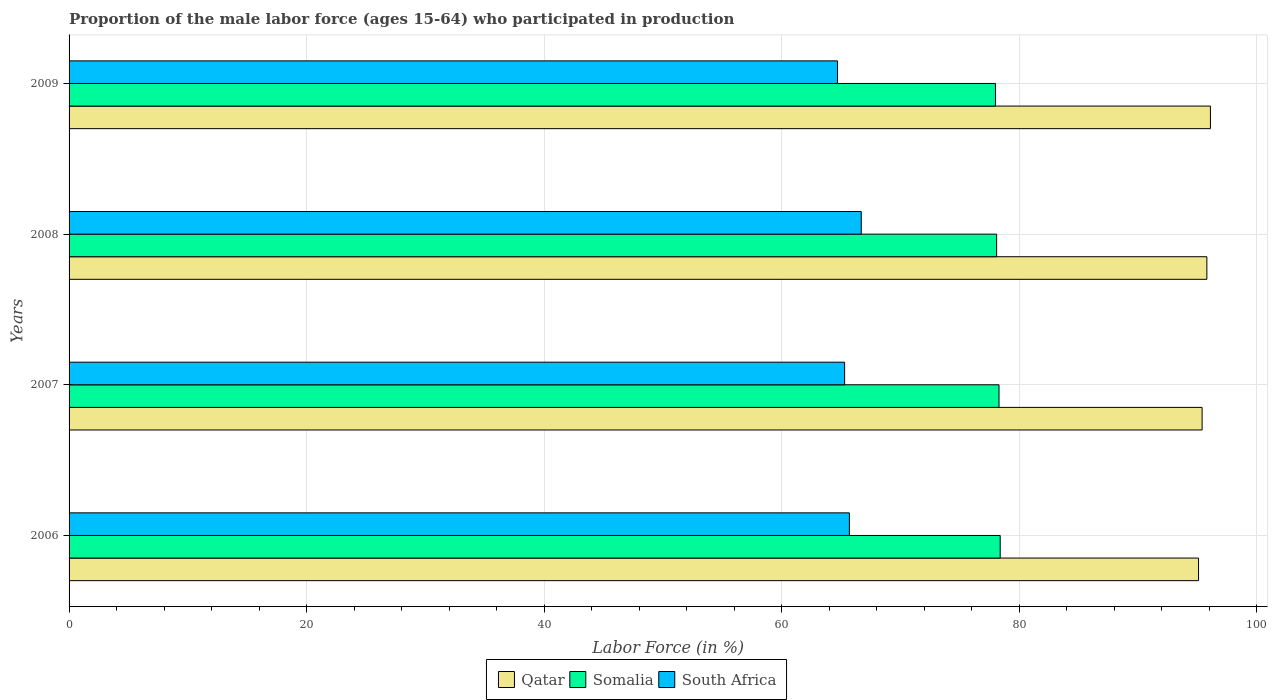How many groups of bars are there?
Offer a very short reply. 4. Are the number of bars on each tick of the Y-axis equal?
Give a very brief answer. Yes. How many bars are there on the 2nd tick from the bottom?
Offer a terse response. 3. In how many cases, is the number of bars for a given year not equal to the number of legend labels?
Your answer should be very brief. 0. What is the proportion of the male labor force who participated in production in Somalia in 2008?
Your answer should be compact. 78.1. Across all years, what is the maximum proportion of the male labor force who participated in production in South Africa?
Provide a short and direct response. 66.7. Across all years, what is the minimum proportion of the male labor force who participated in production in Qatar?
Keep it short and to the point. 95.1. In which year was the proportion of the male labor force who participated in production in Qatar minimum?
Ensure brevity in your answer.  2006. What is the total proportion of the male labor force who participated in production in South Africa in the graph?
Your answer should be compact. 262.4. What is the difference between the proportion of the male labor force who participated in production in Somalia in 2006 and that in 2008?
Your answer should be compact. 0.3. What is the difference between the proportion of the male labor force who participated in production in Somalia in 2009 and the proportion of the male labor force who participated in production in Qatar in 2008?
Offer a very short reply. -17.8. What is the average proportion of the male labor force who participated in production in Somalia per year?
Make the answer very short. 78.2. In the year 2007, what is the difference between the proportion of the male labor force who participated in production in Somalia and proportion of the male labor force who participated in production in Qatar?
Your answer should be very brief. -17.1. What is the ratio of the proportion of the male labor force who participated in production in Somalia in 2006 to that in 2007?
Your response must be concise. 1. Is the proportion of the male labor force who participated in production in South Africa in 2006 less than that in 2008?
Provide a succinct answer. Yes. What is the difference between the highest and the second highest proportion of the male labor force who participated in production in Somalia?
Provide a short and direct response. 0.1. What is the difference between the highest and the lowest proportion of the male labor force who participated in production in Somalia?
Your answer should be compact. 0.4. Is the sum of the proportion of the male labor force who participated in production in South Africa in 2006 and 2009 greater than the maximum proportion of the male labor force who participated in production in Qatar across all years?
Ensure brevity in your answer.  Yes. What does the 3rd bar from the top in 2008 represents?
Provide a short and direct response. Qatar. What does the 3rd bar from the bottom in 2008 represents?
Your answer should be compact. South Africa. Is it the case that in every year, the sum of the proportion of the male labor force who participated in production in Qatar and proportion of the male labor force who participated in production in South Africa is greater than the proportion of the male labor force who participated in production in Somalia?
Your answer should be very brief. Yes. How many bars are there?
Ensure brevity in your answer.  12. How many years are there in the graph?
Give a very brief answer. 4. What is the difference between two consecutive major ticks on the X-axis?
Give a very brief answer. 20. Does the graph contain any zero values?
Your answer should be very brief. No. How are the legend labels stacked?
Keep it short and to the point. Horizontal. What is the title of the graph?
Your response must be concise. Proportion of the male labor force (ages 15-64) who participated in production. Does "Eritrea" appear as one of the legend labels in the graph?
Offer a terse response. No. What is the Labor Force (in %) of Qatar in 2006?
Offer a very short reply. 95.1. What is the Labor Force (in %) of Somalia in 2006?
Keep it short and to the point. 78.4. What is the Labor Force (in %) in South Africa in 2006?
Your answer should be compact. 65.7. What is the Labor Force (in %) in Qatar in 2007?
Keep it short and to the point. 95.4. What is the Labor Force (in %) of Somalia in 2007?
Your answer should be very brief. 78.3. What is the Labor Force (in %) of South Africa in 2007?
Provide a short and direct response. 65.3. What is the Labor Force (in %) in Qatar in 2008?
Your answer should be compact. 95.8. What is the Labor Force (in %) in Somalia in 2008?
Your answer should be compact. 78.1. What is the Labor Force (in %) of South Africa in 2008?
Your answer should be very brief. 66.7. What is the Labor Force (in %) in Qatar in 2009?
Provide a succinct answer. 96.1. What is the Labor Force (in %) in Somalia in 2009?
Make the answer very short. 78. What is the Labor Force (in %) of South Africa in 2009?
Offer a very short reply. 64.7. Across all years, what is the maximum Labor Force (in %) in Qatar?
Keep it short and to the point. 96.1. Across all years, what is the maximum Labor Force (in %) in Somalia?
Your answer should be compact. 78.4. Across all years, what is the maximum Labor Force (in %) in South Africa?
Your answer should be very brief. 66.7. Across all years, what is the minimum Labor Force (in %) of Qatar?
Keep it short and to the point. 95.1. Across all years, what is the minimum Labor Force (in %) in Somalia?
Provide a short and direct response. 78. Across all years, what is the minimum Labor Force (in %) of South Africa?
Provide a short and direct response. 64.7. What is the total Labor Force (in %) in Qatar in the graph?
Give a very brief answer. 382.4. What is the total Labor Force (in %) of Somalia in the graph?
Offer a very short reply. 312.8. What is the total Labor Force (in %) of South Africa in the graph?
Offer a terse response. 262.4. What is the difference between the Labor Force (in %) in Qatar in 2006 and that in 2008?
Keep it short and to the point. -0.7. What is the difference between the Labor Force (in %) of Somalia in 2006 and that in 2008?
Keep it short and to the point. 0.3. What is the difference between the Labor Force (in %) of South Africa in 2006 and that in 2008?
Provide a succinct answer. -1. What is the difference between the Labor Force (in %) of Somalia in 2006 and that in 2009?
Your response must be concise. 0.4. What is the difference between the Labor Force (in %) in South Africa in 2006 and that in 2009?
Give a very brief answer. 1. What is the difference between the Labor Force (in %) in Qatar in 2008 and that in 2009?
Ensure brevity in your answer.  -0.3. What is the difference between the Labor Force (in %) in South Africa in 2008 and that in 2009?
Offer a terse response. 2. What is the difference between the Labor Force (in %) in Qatar in 2006 and the Labor Force (in %) in Somalia in 2007?
Your answer should be very brief. 16.8. What is the difference between the Labor Force (in %) of Qatar in 2006 and the Labor Force (in %) of South Africa in 2007?
Offer a terse response. 29.8. What is the difference between the Labor Force (in %) of Somalia in 2006 and the Labor Force (in %) of South Africa in 2007?
Provide a short and direct response. 13.1. What is the difference between the Labor Force (in %) in Qatar in 2006 and the Labor Force (in %) in Somalia in 2008?
Provide a succinct answer. 17. What is the difference between the Labor Force (in %) of Qatar in 2006 and the Labor Force (in %) of South Africa in 2008?
Offer a terse response. 28.4. What is the difference between the Labor Force (in %) of Somalia in 2006 and the Labor Force (in %) of South Africa in 2008?
Provide a succinct answer. 11.7. What is the difference between the Labor Force (in %) of Qatar in 2006 and the Labor Force (in %) of South Africa in 2009?
Provide a short and direct response. 30.4. What is the difference between the Labor Force (in %) in Qatar in 2007 and the Labor Force (in %) in Somalia in 2008?
Offer a terse response. 17.3. What is the difference between the Labor Force (in %) in Qatar in 2007 and the Labor Force (in %) in South Africa in 2008?
Provide a short and direct response. 28.7. What is the difference between the Labor Force (in %) in Somalia in 2007 and the Labor Force (in %) in South Africa in 2008?
Offer a very short reply. 11.6. What is the difference between the Labor Force (in %) of Qatar in 2007 and the Labor Force (in %) of Somalia in 2009?
Offer a very short reply. 17.4. What is the difference between the Labor Force (in %) in Qatar in 2007 and the Labor Force (in %) in South Africa in 2009?
Provide a short and direct response. 30.7. What is the difference between the Labor Force (in %) of Qatar in 2008 and the Labor Force (in %) of Somalia in 2009?
Give a very brief answer. 17.8. What is the difference between the Labor Force (in %) in Qatar in 2008 and the Labor Force (in %) in South Africa in 2009?
Provide a succinct answer. 31.1. What is the average Labor Force (in %) in Qatar per year?
Your response must be concise. 95.6. What is the average Labor Force (in %) in Somalia per year?
Provide a short and direct response. 78.2. What is the average Labor Force (in %) of South Africa per year?
Ensure brevity in your answer.  65.6. In the year 2006, what is the difference between the Labor Force (in %) of Qatar and Labor Force (in %) of Somalia?
Your answer should be compact. 16.7. In the year 2006, what is the difference between the Labor Force (in %) in Qatar and Labor Force (in %) in South Africa?
Your answer should be compact. 29.4. In the year 2007, what is the difference between the Labor Force (in %) of Qatar and Labor Force (in %) of South Africa?
Provide a short and direct response. 30.1. In the year 2008, what is the difference between the Labor Force (in %) in Qatar and Labor Force (in %) in Somalia?
Offer a very short reply. 17.7. In the year 2008, what is the difference between the Labor Force (in %) of Qatar and Labor Force (in %) of South Africa?
Offer a very short reply. 29.1. In the year 2009, what is the difference between the Labor Force (in %) in Qatar and Labor Force (in %) in South Africa?
Offer a terse response. 31.4. What is the ratio of the Labor Force (in %) of Somalia in 2006 to that in 2007?
Your response must be concise. 1. What is the ratio of the Labor Force (in %) in South Africa in 2006 to that in 2007?
Your answer should be compact. 1.01. What is the ratio of the Labor Force (in %) in Qatar in 2006 to that in 2008?
Your response must be concise. 0.99. What is the ratio of the Labor Force (in %) of Somalia in 2006 to that in 2008?
Offer a very short reply. 1. What is the ratio of the Labor Force (in %) in Qatar in 2006 to that in 2009?
Offer a terse response. 0.99. What is the ratio of the Labor Force (in %) in Somalia in 2006 to that in 2009?
Your response must be concise. 1.01. What is the ratio of the Labor Force (in %) in South Africa in 2006 to that in 2009?
Provide a short and direct response. 1.02. What is the ratio of the Labor Force (in %) of South Africa in 2007 to that in 2009?
Give a very brief answer. 1.01. What is the ratio of the Labor Force (in %) of South Africa in 2008 to that in 2009?
Give a very brief answer. 1.03. What is the difference between the highest and the second highest Labor Force (in %) of Qatar?
Give a very brief answer. 0.3. What is the difference between the highest and the second highest Labor Force (in %) of Somalia?
Offer a terse response. 0.1. What is the difference between the highest and the lowest Labor Force (in %) of Somalia?
Your answer should be very brief. 0.4. 